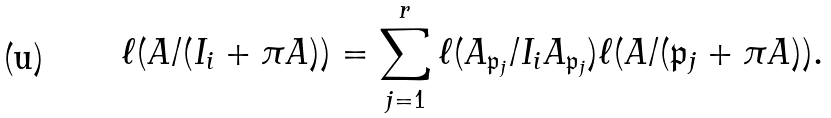<formula> <loc_0><loc_0><loc_500><loc_500>\ell ( A / ( I _ { i } + \pi A ) ) = \sum _ { j = 1 } ^ { r } \ell ( A _ { \mathfrak p _ { j } } / I _ { i } A _ { \mathfrak p _ { j } } ) \ell ( A / ( \mathfrak p _ { j } + \pi A ) ) .</formula> 